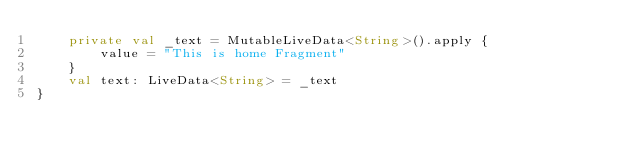<code> <loc_0><loc_0><loc_500><loc_500><_Kotlin_>    private val _text = MutableLiveData<String>().apply {
        value = "This is home Fragment"
    }
    val text: LiveData<String> = _text
}</code> 